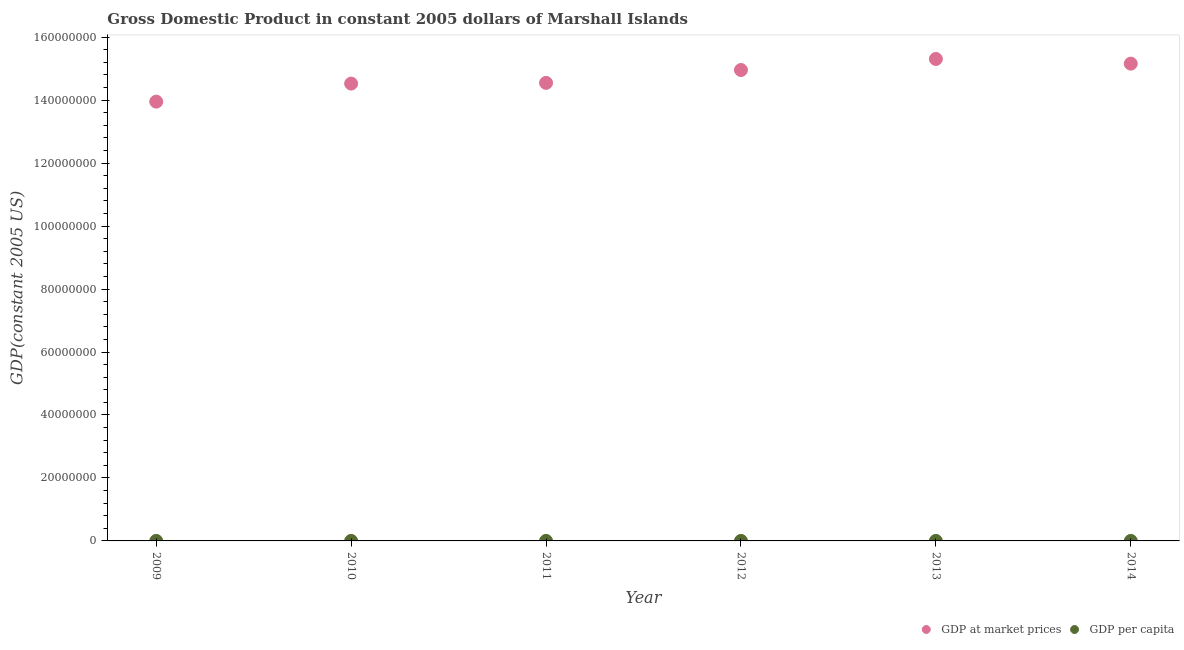How many different coloured dotlines are there?
Provide a short and direct response. 2. What is the gdp per capita in 2009?
Offer a very short reply. 2666.48. Across all years, what is the maximum gdp at market prices?
Give a very brief answer. 1.53e+08. Across all years, what is the minimum gdp per capita?
Give a very brief answer. 2666.48. What is the total gdp at market prices in the graph?
Keep it short and to the point. 8.84e+08. What is the difference between the gdp at market prices in 2011 and that in 2012?
Your response must be concise. -4.09e+06. What is the difference between the gdp at market prices in 2011 and the gdp per capita in 2009?
Your answer should be very brief. 1.45e+08. What is the average gdp per capita per year?
Your answer should be very brief. 2801.77. In the year 2009, what is the difference between the gdp per capita and gdp at market prices?
Offer a very short reply. -1.40e+08. In how many years, is the gdp at market prices greater than 92000000 US$?
Keep it short and to the point. 6. What is the ratio of the gdp at market prices in 2009 to that in 2012?
Provide a succinct answer. 0.93. Is the difference between the gdp per capita in 2010 and 2014 greater than the difference between the gdp at market prices in 2010 and 2014?
Provide a short and direct response. Yes. What is the difference between the highest and the second highest gdp at market prices?
Offer a terse response. 1.49e+06. What is the difference between the highest and the lowest gdp at market prices?
Your answer should be very brief. 1.36e+07. Is the sum of the gdp at market prices in 2011 and 2014 greater than the maximum gdp per capita across all years?
Ensure brevity in your answer.  Yes. Does the gdp at market prices monotonically increase over the years?
Make the answer very short. No. Is the gdp at market prices strictly greater than the gdp per capita over the years?
Your response must be concise. Yes. Is the gdp at market prices strictly less than the gdp per capita over the years?
Offer a terse response. No. What is the difference between two consecutive major ticks on the Y-axis?
Your answer should be compact. 2.00e+07. Does the graph contain any zero values?
Make the answer very short. No. Does the graph contain grids?
Provide a succinct answer. No. Where does the legend appear in the graph?
Make the answer very short. Bottom right. How many legend labels are there?
Keep it short and to the point. 2. What is the title of the graph?
Provide a short and direct response. Gross Domestic Product in constant 2005 dollars of Marshall Islands. Does "Nitrous oxide emissions" appear as one of the legend labels in the graph?
Your response must be concise. No. What is the label or title of the X-axis?
Your answer should be very brief. Year. What is the label or title of the Y-axis?
Keep it short and to the point. GDP(constant 2005 US). What is the GDP(constant 2005 US) of GDP at market prices in 2009?
Offer a very short reply. 1.40e+08. What is the GDP(constant 2005 US) of GDP per capita in 2009?
Make the answer very short. 2666.48. What is the GDP(constant 2005 US) of GDP at market prices in 2010?
Make the answer very short. 1.45e+08. What is the GDP(constant 2005 US) of GDP per capita in 2010?
Keep it short and to the point. 2770.38. What is the GDP(constant 2005 US) of GDP at market prices in 2011?
Offer a terse response. 1.45e+08. What is the GDP(constant 2005 US) in GDP per capita in 2011?
Your answer should be compact. 2768.65. What is the GDP(constant 2005 US) of GDP at market prices in 2012?
Provide a succinct answer. 1.50e+08. What is the GDP(constant 2005 US) of GDP per capita in 2012?
Keep it short and to the point. 2839.97. What is the GDP(constant 2005 US) of GDP at market prices in 2013?
Offer a terse response. 1.53e+08. What is the GDP(constant 2005 US) of GDP per capita in 2013?
Keep it short and to the point. 2899.71. What is the GDP(constant 2005 US) of GDP at market prices in 2014?
Your answer should be very brief. 1.52e+08. What is the GDP(constant 2005 US) of GDP per capita in 2014?
Offer a terse response. 2865.46. Across all years, what is the maximum GDP(constant 2005 US) of GDP at market prices?
Your response must be concise. 1.53e+08. Across all years, what is the maximum GDP(constant 2005 US) of GDP per capita?
Your answer should be very brief. 2899.71. Across all years, what is the minimum GDP(constant 2005 US) in GDP at market prices?
Offer a terse response. 1.40e+08. Across all years, what is the minimum GDP(constant 2005 US) in GDP per capita?
Keep it short and to the point. 2666.48. What is the total GDP(constant 2005 US) of GDP at market prices in the graph?
Give a very brief answer. 8.84e+08. What is the total GDP(constant 2005 US) in GDP per capita in the graph?
Provide a short and direct response. 1.68e+04. What is the difference between the GDP(constant 2005 US) of GDP at market prices in 2009 and that in 2010?
Offer a very short reply. -5.73e+06. What is the difference between the GDP(constant 2005 US) of GDP per capita in 2009 and that in 2010?
Your answer should be very brief. -103.91. What is the difference between the GDP(constant 2005 US) in GDP at market prices in 2009 and that in 2011?
Provide a succinct answer. -5.95e+06. What is the difference between the GDP(constant 2005 US) in GDP per capita in 2009 and that in 2011?
Provide a short and direct response. -102.17. What is the difference between the GDP(constant 2005 US) in GDP at market prices in 2009 and that in 2012?
Your answer should be compact. -1.00e+07. What is the difference between the GDP(constant 2005 US) in GDP per capita in 2009 and that in 2012?
Provide a succinct answer. -173.49. What is the difference between the GDP(constant 2005 US) of GDP at market prices in 2009 and that in 2013?
Provide a succinct answer. -1.36e+07. What is the difference between the GDP(constant 2005 US) in GDP per capita in 2009 and that in 2013?
Provide a succinct answer. -233.23. What is the difference between the GDP(constant 2005 US) in GDP at market prices in 2009 and that in 2014?
Your answer should be compact. -1.21e+07. What is the difference between the GDP(constant 2005 US) in GDP per capita in 2009 and that in 2014?
Your answer should be very brief. -198.99. What is the difference between the GDP(constant 2005 US) in GDP at market prices in 2010 and that in 2011?
Ensure brevity in your answer.  -2.22e+05. What is the difference between the GDP(constant 2005 US) in GDP per capita in 2010 and that in 2011?
Offer a terse response. 1.74. What is the difference between the GDP(constant 2005 US) of GDP at market prices in 2010 and that in 2012?
Offer a terse response. -4.32e+06. What is the difference between the GDP(constant 2005 US) in GDP per capita in 2010 and that in 2012?
Your answer should be compact. -69.59. What is the difference between the GDP(constant 2005 US) in GDP at market prices in 2010 and that in 2013?
Provide a short and direct response. -7.82e+06. What is the difference between the GDP(constant 2005 US) of GDP per capita in 2010 and that in 2013?
Offer a very short reply. -129.33. What is the difference between the GDP(constant 2005 US) in GDP at market prices in 2010 and that in 2014?
Ensure brevity in your answer.  -6.33e+06. What is the difference between the GDP(constant 2005 US) in GDP per capita in 2010 and that in 2014?
Make the answer very short. -95.08. What is the difference between the GDP(constant 2005 US) in GDP at market prices in 2011 and that in 2012?
Provide a succinct answer. -4.09e+06. What is the difference between the GDP(constant 2005 US) in GDP per capita in 2011 and that in 2012?
Make the answer very short. -71.32. What is the difference between the GDP(constant 2005 US) in GDP at market prices in 2011 and that in 2013?
Offer a very short reply. -7.60e+06. What is the difference between the GDP(constant 2005 US) in GDP per capita in 2011 and that in 2013?
Give a very brief answer. -131.06. What is the difference between the GDP(constant 2005 US) of GDP at market prices in 2011 and that in 2014?
Your answer should be very brief. -6.11e+06. What is the difference between the GDP(constant 2005 US) of GDP per capita in 2011 and that in 2014?
Provide a succinct answer. -96.82. What is the difference between the GDP(constant 2005 US) of GDP at market prices in 2012 and that in 2013?
Keep it short and to the point. -3.50e+06. What is the difference between the GDP(constant 2005 US) of GDP per capita in 2012 and that in 2013?
Make the answer very short. -59.74. What is the difference between the GDP(constant 2005 US) in GDP at market prices in 2012 and that in 2014?
Offer a very short reply. -2.02e+06. What is the difference between the GDP(constant 2005 US) of GDP per capita in 2012 and that in 2014?
Make the answer very short. -25.5. What is the difference between the GDP(constant 2005 US) in GDP at market prices in 2013 and that in 2014?
Keep it short and to the point. 1.49e+06. What is the difference between the GDP(constant 2005 US) of GDP per capita in 2013 and that in 2014?
Make the answer very short. 34.24. What is the difference between the GDP(constant 2005 US) in GDP at market prices in 2009 and the GDP(constant 2005 US) in GDP per capita in 2010?
Keep it short and to the point. 1.40e+08. What is the difference between the GDP(constant 2005 US) in GDP at market prices in 2009 and the GDP(constant 2005 US) in GDP per capita in 2011?
Provide a short and direct response. 1.40e+08. What is the difference between the GDP(constant 2005 US) of GDP at market prices in 2009 and the GDP(constant 2005 US) of GDP per capita in 2012?
Offer a very short reply. 1.40e+08. What is the difference between the GDP(constant 2005 US) of GDP at market prices in 2009 and the GDP(constant 2005 US) of GDP per capita in 2013?
Your response must be concise. 1.40e+08. What is the difference between the GDP(constant 2005 US) in GDP at market prices in 2009 and the GDP(constant 2005 US) in GDP per capita in 2014?
Offer a very short reply. 1.40e+08. What is the difference between the GDP(constant 2005 US) in GDP at market prices in 2010 and the GDP(constant 2005 US) in GDP per capita in 2011?
Offer a terse response. 1.45e+08. What is the difference between the GDP(constant 2005 US) in GDP at market prices in 2010 and the GDP(constant 2005 US) in GDP per capita in 2012?
Your answer should be compact. 1.45e+08. What is the difference between the GDP(constant 2005 US) of GDP at market prices in 2010 and the GDP(constant 2005 US) of GDP per capita in 2013?
Your answer should be very brief. 1.45e+08. What is the difference between the GDP(constant 2005 US) in GDP at market prices in 2010 and the GDP(constant 2005 US) in GDP per capita in 2014?
Your response must be concise. 1.45e+08. What is the difference between the GDP(constant 2005 US) in GDP at market prices in 2011 and the GDP(constant 2005 US) in GDP per capita in 2012?
Offer a very short reply. 1.45e+08. What is the difference between the GDP(constant 2005 US) of GDP at market prices in 2011 and the GDP(constant 2005 US) of GDP per capita in 2013?
Give a very brief answer. 1.45e+08. What is the difference between the GDP(constant 2005 US) of GDP at market prices in 2011 and the GDP(constant 2005 US) of GDP per capita in 2014?
Make the answer very short. 1.45e+08. What is the difference between the GDP(constant 2005 US) in GDP at market prices in 2012 and the GDP(constant 2005 US) in GDP per capita in 2013?
Provide a short and direct response. 1.50e+08. What is the difference between the GDP(constant 2005 US) in GDP at market prices in 2012 and the GDP(constant 2005 US) in GDP per capita in 2014?
Make the answer very short. 1.50e+08. What is the difference between the GDP(constant 2005 US) of GDP at market prices in 2013 and the GDP(constant 2005 US) of GDP per capita in 2014?
Provide a succinct answer. 1.53e+08. What is the average GDP(constant 2005 US) of GDP at market prices per year?
Make the answer very short. 1.47e+08. What is the average GDP(constant 2005 US) in GDP per capita per year?
Your response must be concise. 2801.77. In the year 2009, what is the difference between the GDP(constant 2005 US) in GDP at market prices and GDP(constant 2005 US) in GDP per capita?
Offer a terse response. 1.40e+08. In the year 2010, what is the difference between the GDP(constant 2005 US) of GDP at market prices and GDP(constant 2005 US) of GDP per capita?
Provide a succinct answer. 1.45e+08. In the year 2011, what is the difference between the GDP(constant 2005 US) in GDP at market prices and GDP(constant 2005 US) in GDP per capita?
Ensure brevity in your answer.  1.45e+08. In the year 2012, what is the difference between the GDP(constant 2005 US) in GDP at market prices and GDP(constant 2005 US) in GDP per capita?
Offer a very short reply. 1.50e+08. In the year 2013, what is the difference between the GDP(constant 2005 US) in GDP at market prices and GDP(constant 2005 US) in GDP per capita?
Provide a short and direct response. 1.53e+08. In the year 2014, what is the difference between the GDP(constant 2005 US) of GDP at market prices and GDP(constant 2005 US) of GDP per capita?
Your response must be concise. 1.52e+08. What is the ratio of the GDP(constant 2005 US) of GDP at market prices in 2009 to that in 2010?
Offer a very short reply. 0.96. What is the ratio of the GDP(constant 2005 US) of GDP per capita in 2009 to that in 2010?
Keep it short and to the point. 0.96. What is the ratio of the GDP(constant 2005 US) of GDP at market prices in 2009 to that in 2011?
Provide a short and direct response. 0.96. What is the ratio of the GDP(constant 2005 US) of GDP per capita in 2009 to that in 2011?
Make the answer very short. 0.96. What is the ratio of the GDP(constant 2005 US) of GDP at market prices in 2009 to that in 2012?
Your answer should be very brief. 0.93. What is the ratio of the GDP(constant 2005 US) of GDP per capita in 2009 to that in 2012?
Offer a terse response. 0.94. What is the ratio of the GDP(constant 2005 US) of GDP at market prices in 2009 to that in 2013?
Ensure brevity in your answer.  0.91. What is the ratio of the GDP(constant 2005 US) of GDP per capita in 2009 to that in 2013?
Your answer should be very brief. 0.92. What is the ratio of the GDP(constant 2005 US) of GDP at market prices in 2009 to that in 2014?
Your response must be concise. 0.92. What is the ratio of the GDP(constant 2005 US) in GDP per capita in 2009 to that in 2014?
Your answer should be compact. 0.93. What is the ratio of the GDP(constant 2005 US) of GDP per capita in 2010 to that in 2011?
Your answer should be very brief. 1. What is the ratio of the GDP(constant 2005 US) of GDP at market prices in 2010 to that in 2012?
Your answer should be very brief. 0.97. What is the ratio of the GDP(constant 2005 US) in GDP per capita in 2010 to that in 2012?
Make the answer very short. 0.98. What is the ratio of the GDP(constant 2005 US) of GDP at market prices in 2010 to that in 2013?
Keep it short and to the point. 0.95. What is the ratio of the GDP(constant 2005 US) in GDP per capita in 2010 to that in 2013?
Give a very brief answer. 0.96. What is the ratio of the GDP(constant 2005 US) in GDP at market prices in 2010 to that in 2014?
Give a very brief answer. 0.96. What is the ratio of the GDP(constant 2005 US) in GDP per capita in 2010 to that in 2014?
Your answer should be very brief. 0.97. What is the ratio of the GDP(constant 2005 US) of GDP at market prices in 2011 to that in 2012?
Your answer should be very brief. 0.97. What is the ratio of the GDP(constant 2005 US) in GDP per capita in 2011 to that in 2012?
Offer a very short reply. 0.97. What is the ratio of the GDP(constant 2005 US) in GDP at market prices in 2011 to that in 2013?
Give a very brief answer. 0.95. What is the ratio of the GDP(constant 2005 US) in GDP per capita in 2011 to that in 2013?
Make the answer very short. 0.95. What is the ratio of the GDP(constant 2005 US) of GDP at market prices in 2011 to that in 2014?
Your answer should be very brief. 0.96. What is the ratio of the GDP(constant 2005 US) in GDP per capita in 2011 to that in 2014?
Offer a very short reply. 0.97. What is the ratio of the GDP(constant 2005 US) of GDP at market prices in 2012 to that in 2013?
Provide a short and direct response. 0.98. What is the ratio of the GDP(constant 2005 US) in GDP per capita in 2012 to that in 2013?
Offer a very short reply. 0.98. What is the ratio of the GDP(constant 2005 US) in GDP at market prices in 2012 to that in 2014?
Your answer should be very brief. 0.99. What is the ratio of the GDP(constant 2005 US) in GDP at market prices in 2013 to that in 2014?
Ensure brevity in your answer.  1.01. What is the ratio of the GDP(constant 2005 US) of GDP per capita in 2013 to that in 2014?
Provide a succinct answer. 1.01. What is the difference between the highest and the second highest GDP(constant 2005 US) in GDP at market prices?
Make the answer very short. 1.49e+06. What is the difference between the highest and the second highest GDP(constant 2005 US) in GDP per capita?
Offer a terse response. 34.24. What is the difference between the highest and the lowest GDP(constant 2005 US) in GDP at market prices?
Your answer should be very brief. 1.36e+07. What is the difference between the highest and the lowest GDP(constant 2005 US) of GDP per capita?
Offer a terse response. 233.23. 